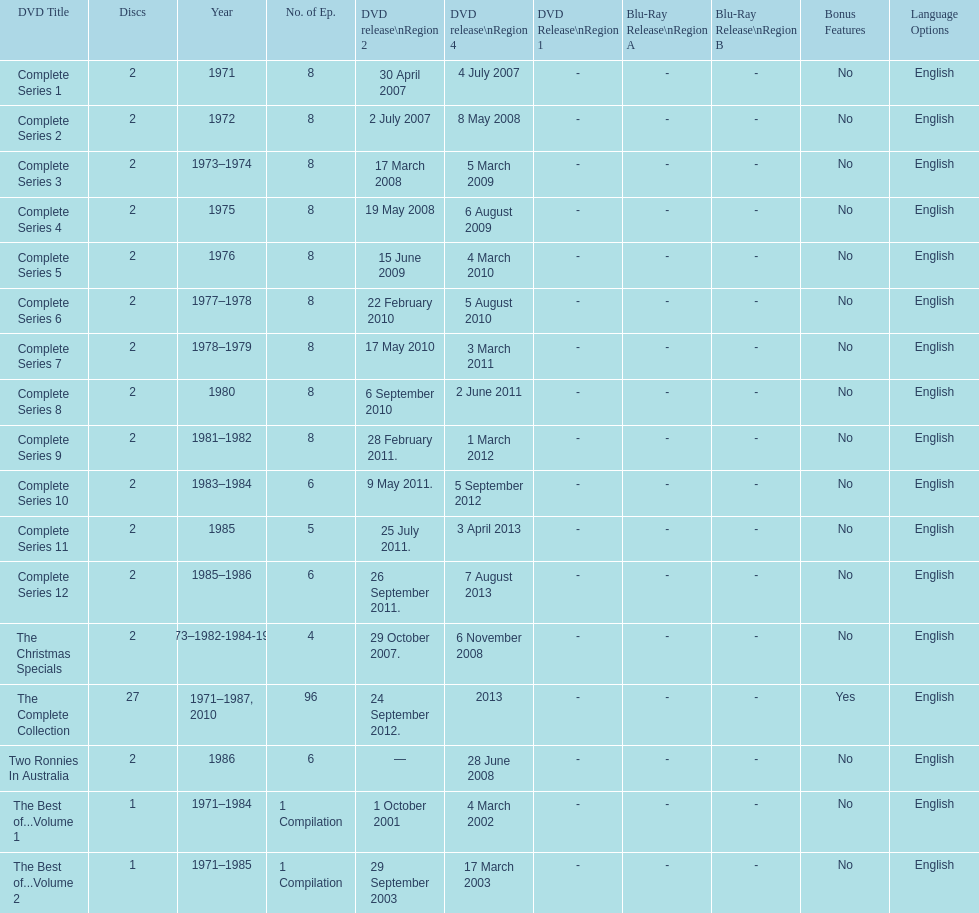What is previous to complete series 10? Complete Series 9. 